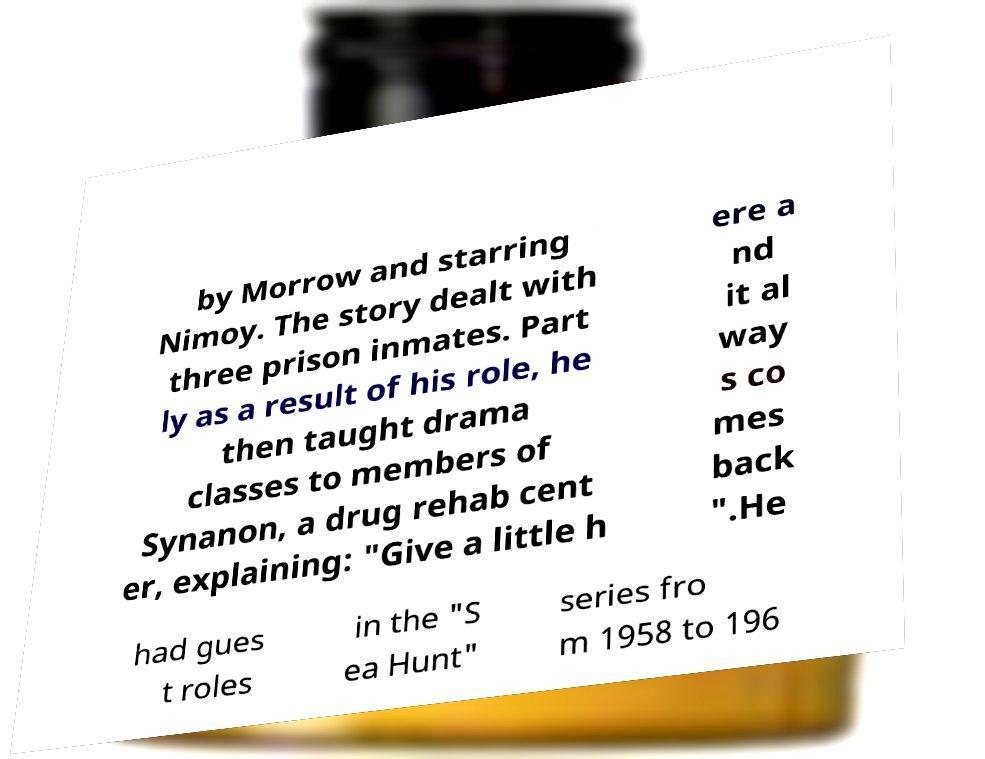There's text embedded in this image that I need extracted. Can you transcribe it verbatim? by Morrow and starring Nimoy. The story dealt with three prison inmates. Part ly as a result of his role, he then taught drama classes to members of Synanon, a drug rehab cent er, explaining: "Give a little h ere a nd it al way s co mes back ".He had gues t roles in the "S ea Hunt" series fro m 1958 to 196 